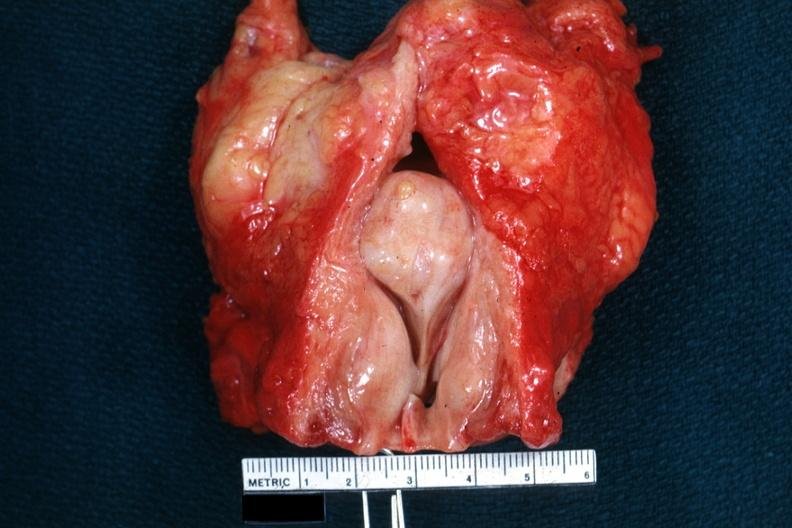does so-called median bar not show bladder well?
Answer the question using a single word or phrase. Yes 